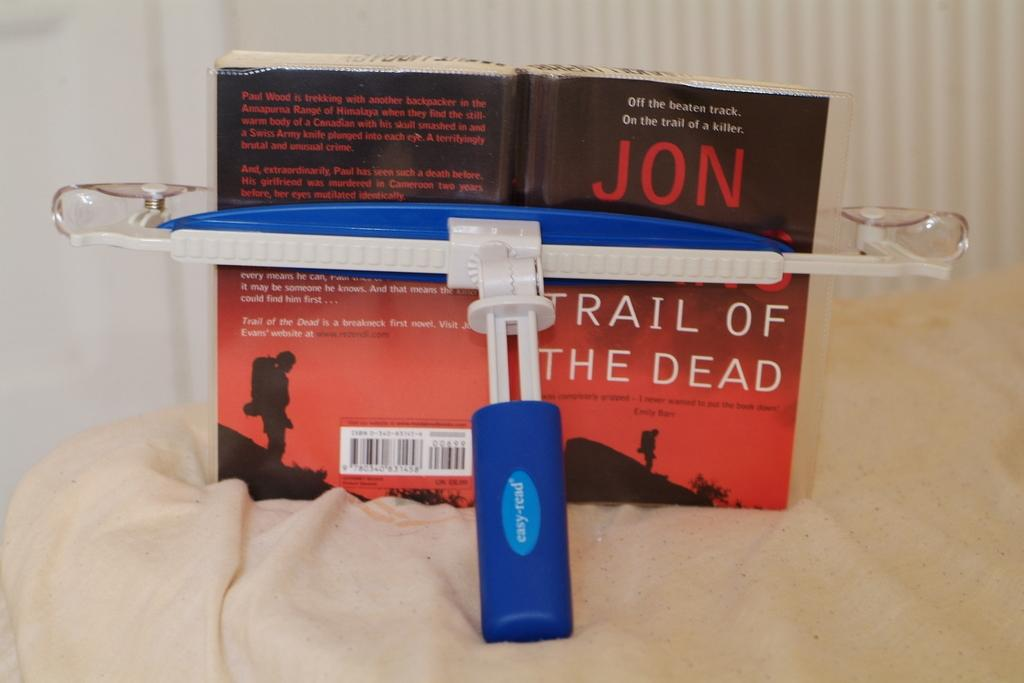<image>
Describe the image concisely. The book Trail of the Dead written by someone named Jon. 